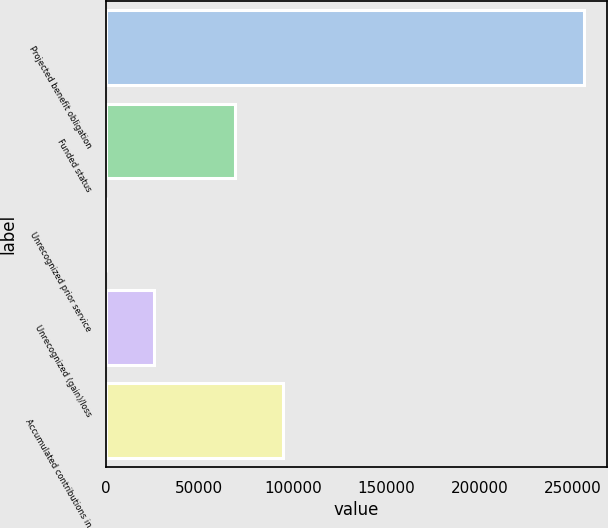Convert chart. <chart><loc_0><loc_0><loc_500><loc_500><bar_chart><fcel>Projected benefit obligation<fcel>Funded status<fcel>Unrecognized prior service<fcel>Unrecognized (gain)/loss<fcel>Accumulated contributions in<nl><fcel>255541<fcel>69096<fcel>284<fcel>25809.7<fcel>94732<nl></chart> 